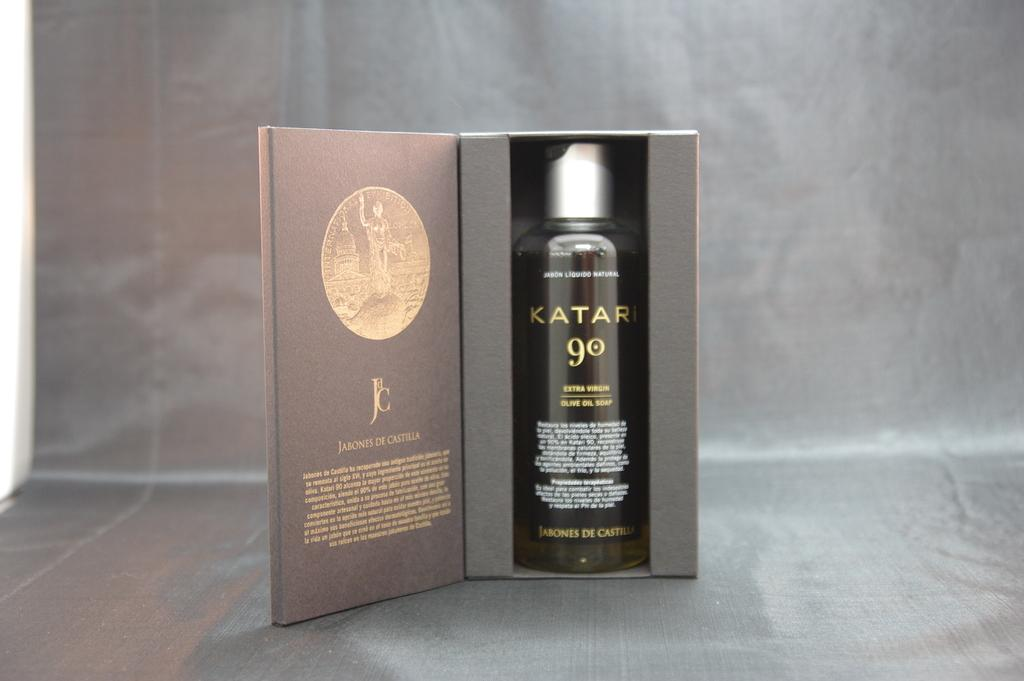<image>
Present a compact description of the photo's key features. a Katar 90 bottle still in the box. 